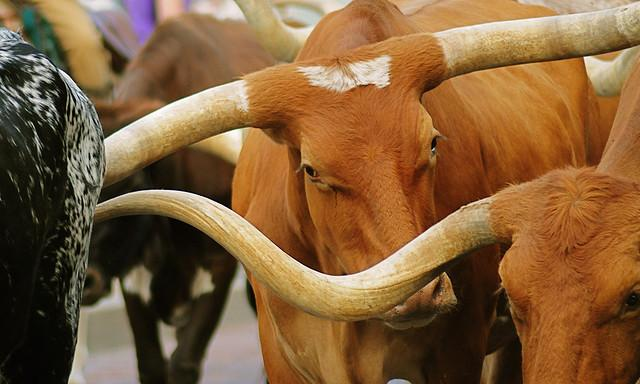What are long horn cows called? longhorns 